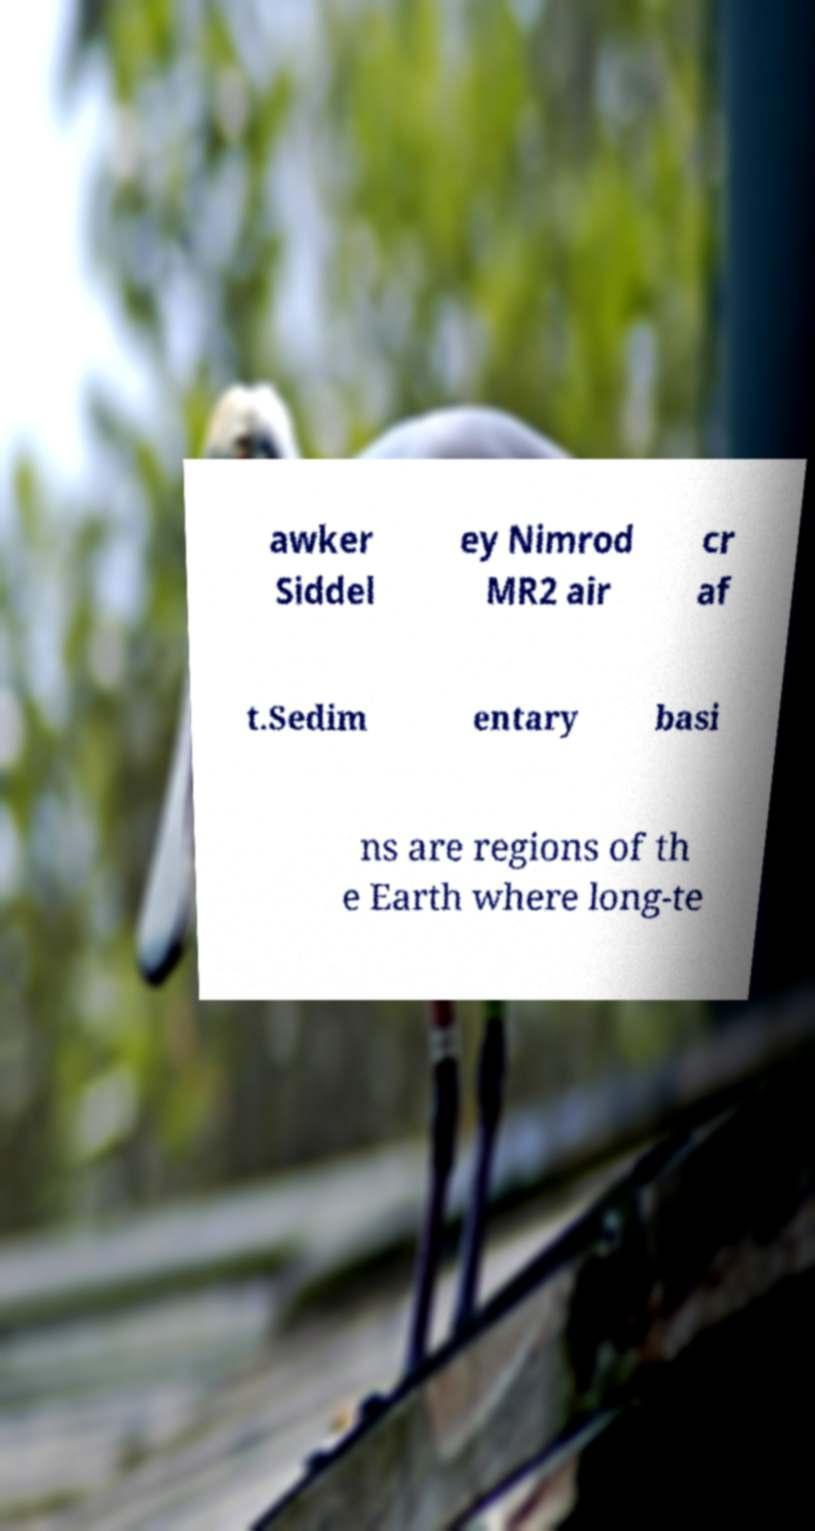There's text embedded in this image that I need extracted. Can you transcribe it verbatim? awker Siddel ey Nimrod MR2 air cr af t.Sedim entary basi ns are regions of th e Earth where long-te 